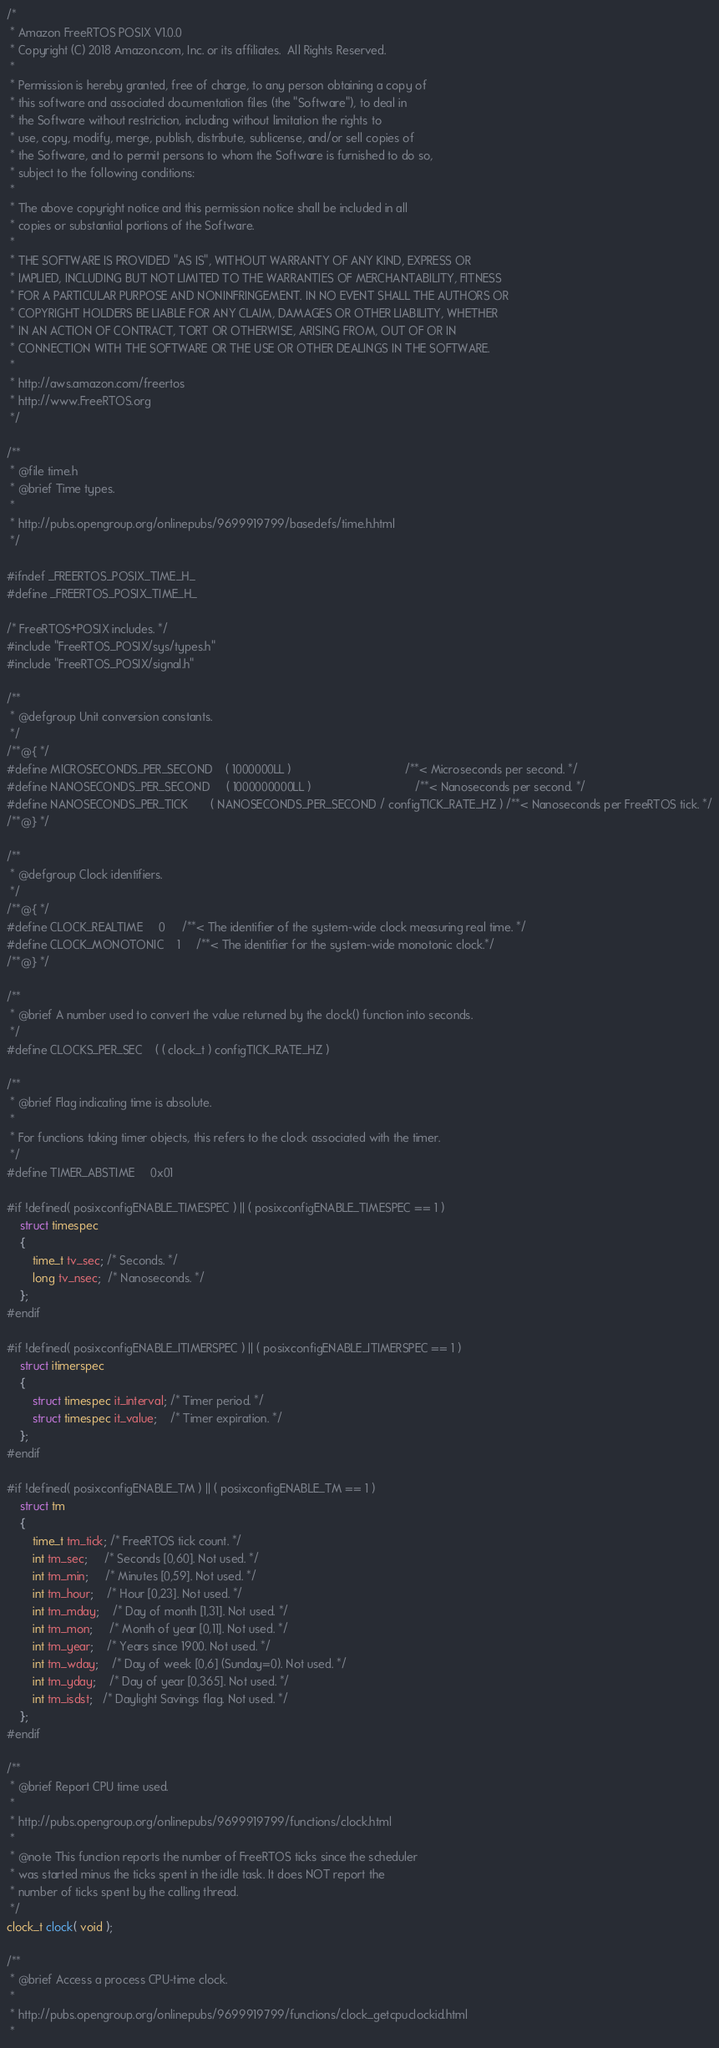<code> <loc_0><loc_0><loc_500><loc_500><_C_>/*
 * Amazon FreeRTOS POSIX V1.0.0
 * Copyright (C) 2018 Amazon.com, Inc. or its affiliates.  All Rights Reserved.
 *
 * Permission is hereby granted, free of charge, to any person obtaining a copy of
 * this software and associated documentation files (the "Software"), to deal in
 * the Software without restriction, including without limitation the rights to
 * use, copy, modify, merge, publish, distribute, sublicense, and/or sell copies of
 * the Software, and to permit persons to whom the Software is furnished to do so,
 * subject to the following conditions:
 *
 * The above copyright notice and this permission notice shall be included in all
 * copies or substantial portions of the Software.
 *
 * THE SOFTWARE IS PROVIDED "AS IS", WITHOUT WARRANTY OF ANY KIND, EXPRESS OR
 * IMPLIED, INCLUDING BUT NOT LIMITED TO THE WARRANTIES OF MERCHANTABILITY, FITNESS
 * FOR A PARTICULAR PURPOSE AND NONINFRINGEMENT. IN NO EVENT SHALL THE AUTHORS OR
 * COPYRIGHT HOLDERS BE LIABLE FOR ANY CLAIM, DAMAGES OR OTHER LIABILITY, WHETHER
 * IN AN ACTION OF CONTRACT, TORT OR OTHERWISE, ARISING FROM, OUT OF OR IN
 * CONNECTION WITH THE SOFTWARE OR THE USE OR OTHER DEALINGS IN THE SOFTWARE.
 *
 * http://aws.amazon.com/freertos
 * http://www.FreeRTOS.org
 */

/**
 * @file time.h
 * @brief Time types.
 *
 * http://pubs.opengroup.org/onlinepubs/9699919799/basedefs/time.h.html
 */

#ifndef _FREERTOS_POSIX_TIME_H_
#define _FREERTOS_POSIX_TIME_H_

/* FreeRTOS+POSIX includes. */
#include "FreeRTOS_POSIX/sys/types.h"
#include "FreeRTOS_POSIX/signal.h"

/**
 * @defgroup Unit conversion constants.
 */
/**@{ */
#define MICROSECONDS_PER_SECOND    ( 1000000LL )                                   /**< Microseconds per second. */
#define NANOSECONDS_PER_SECOND     ( 1000000000LL )                                /**< Nanoseconds per second. */
#define NANOSECONDS_PER_TICK       ( NANOSECONDS_PER_SECOND / configTICK_RATE_HZ ) /**< Nanoseconds per FreeRTOS tick. */
/**@} */

/**
 * @defgroup Clock identifiers.
 */
/**@{ */
#define CLOCK_REALTIME     0     /**< The identifier of the system-wide clock measuring real time. */
#define CLOCK_MONOTONIC    1     /**< The identifier for the system-wide monotonic clock.*/
/**@} */

/**
 * @brief A number used to convert the value returned by the clock() function into seconds.
 */
#define CLOCKS_PER_SEC    ( ( clock_t ) configTICK_RATE_HZ )

/**
 * @brief Flag indicating time is absolute.
 *
 * For functions taking timer objects, this refers to the clock associated with the timer.
 */
#define TIMER_ABSTIME     0x01

#if !defined( posixconfigENABLE_TIMESPEC ) || ( posixconfigENABLE_TIMESPEC == 1 )
    struct timespec
    {
        time_t tv_sec; /* Seconds. */
        long tv_nsec;  /* Nanoseconds. */
    };
#endif

#if !defined( posixconfigENABLE_ITIMERSPEC ) || ( posixconfigENABLE_ITIMERSPEC == 1 )
    struct itimerspec
    {
        struct timespec it_interval; /* Timer period. */
        struct timespec it_value;    /* Timer expiration. */
    };
#endif

#if !defined( posixconfigENABLE_TM ) || ( posixconfigENABLE_TM == 1 )
    struct tm
    {
        time_t tm_tick; /* FreeRTOS tick count. */
        int tm_sec;     /* Seconds [0,60]. Not used. */
        int tm_min;     /* Minutes [0,59]. Not used. */
        int tm_hour;    /* Hour [0,23]. Not used. */
        int tm_mday;    /* Day of month [1,31]. Not used. */
        int tm_mon;     /* Month of year [0,11]. Not used. */
        int tm_year;    /* Years since 1900. Not used. */
        int tm_wday;    /* Day of week [0,6] (Sunday=0). Not used. */
        int tm_yday;    /* Day of year [0,365]. Not used. */
        int tm_isdst;   /* Daylight Savings flag. Not used. */
    };
#endif

/**
 * @brief Report CPU time used.
 *
 * http://pubs.opengroup.org/onlinepubs/9699919799/functions/clock.html
 *
 * @note This function reports the number of FreeRTOS ticks since the scheduler
 * was started minus the ticks spent in the idle task. It does NOT report the
 * number of ticks spent by the calling thread.
 */
clock_t clock( void );

/**
 * @brief Access a process CPU-time clock.
 *
 * http://pubs.opengroup.org/onlinepubs/9699919799/functions/clock_getcpuclockid.html
 *</code> 